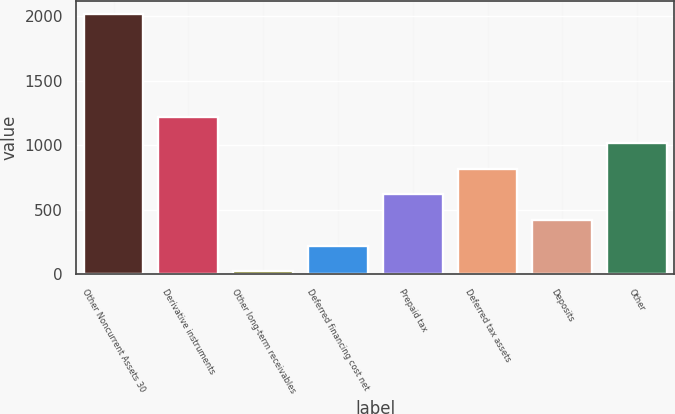Convert chart. <chart><loc_0><loc_0><loc_500><loc_500><bar_chart><fcel>Other Noncurrent Assets 30<fcel>Derivative instruments<fcel>Other long-term receivables<fcel>Deferred financing cost net<fcel>Prepaid tax<fcel>Deferred tax assets<fcel>Deposits<fcel>Other<nl><fcel>2016<fcel>1217.84<fcel>20.6<fcel>220.14<fcel>619.22<fcel>818.76<fcel>419.68<fcel>1018.3<nl></chart> 